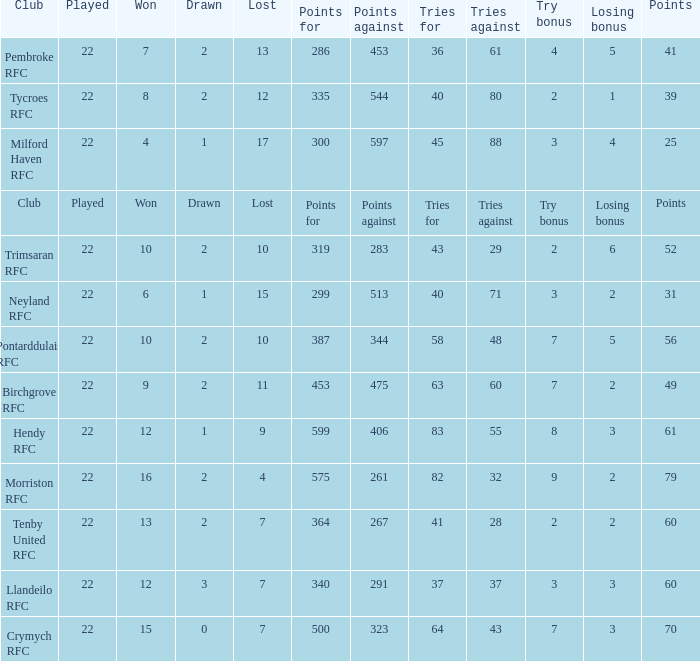 how many points against with tries for being 43 1.0. 